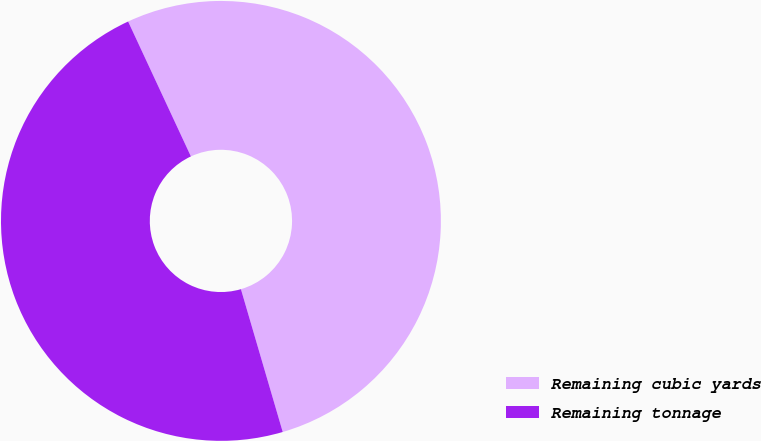Convert chart. <chart><loc_0><loc_0><loc_500><loc_500><pie_chart><fcel>Remaining cubic yards<fcel>Remaining tonnage<nl><fcel>52.4%<fcel>47.6%<nl></chart> 